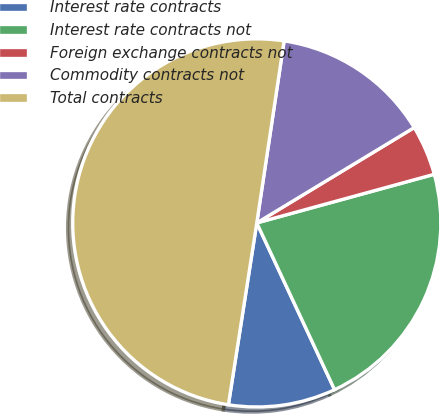<chart> <loc_0><loc_0><loc_500><loc_500><pie_chart><fcel>Interest rate contracts<fcel>Interest rate contracts not<fcel>Foreign exchange contracts not<fcel>Commodity contracts not<fcel>Total contracts<nl><fcel>9.41%<fcel>22.31%<fcel>4.41%<fcel>13.96%<fcel>49.91%<nl></chart> 